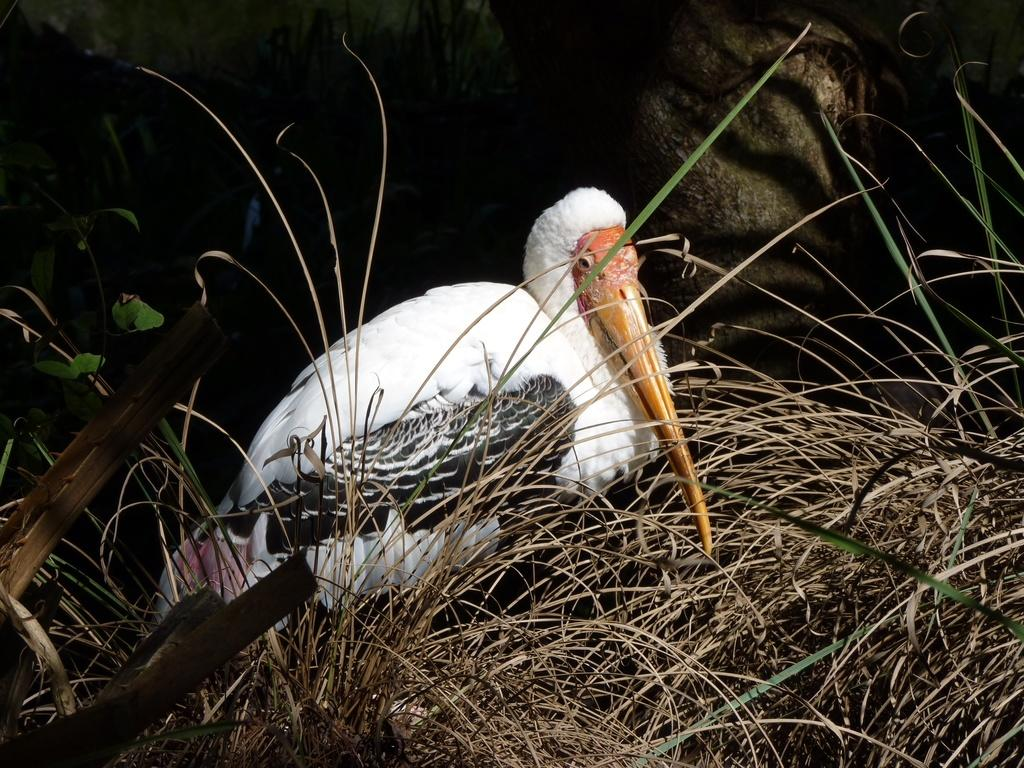What type of bird is in the image? There is a white crane with a yellow peak in the image. What type of vegetation is present in the image? There is dried grass in the image. What is the color of the background in the image? The background of the image is dark. What type of soup is being served in the image? There is no soup present in the image; it features a white crane with a yellow peak and dried grass. How is the string used in the image? There is no string present in the image. 